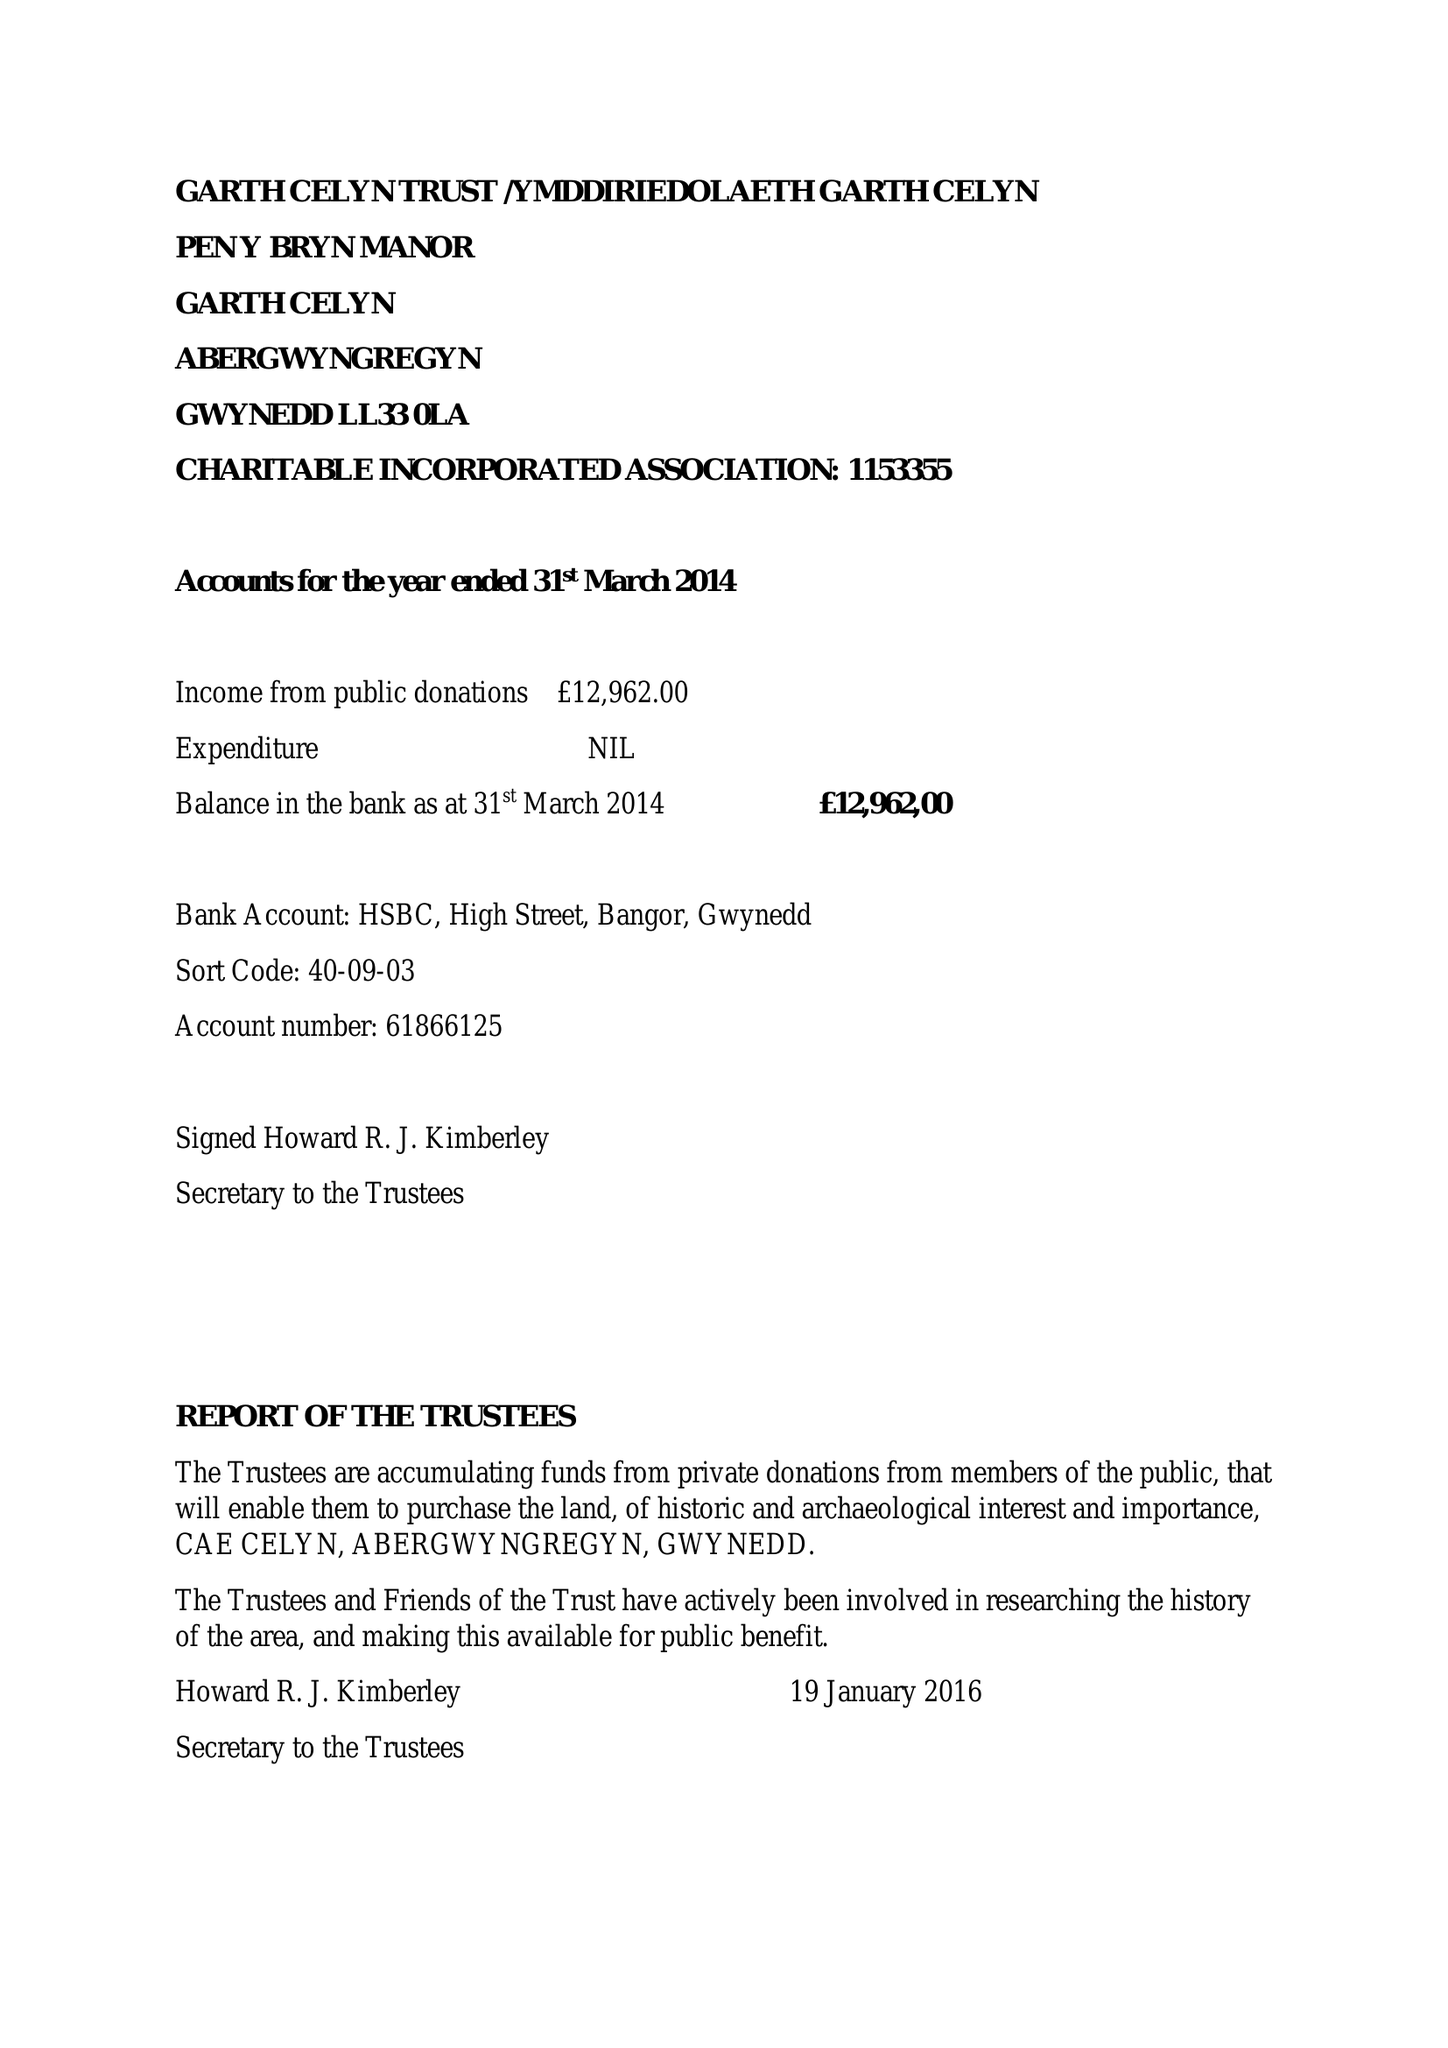What is the value for the address__post_town?
Answer the question using a single word or phrase. LLANFAIRFECHAN 